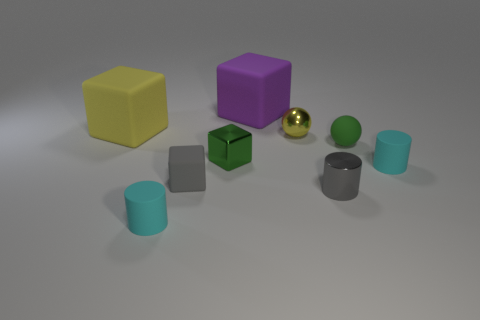What material is the tiny cylinder that is the same color as the tiny matte block?
Provide a short and direct response. Metal. What number of tiny green balls are the same material as the small yellow sphere?
Your answer should be compact. 0. What size is the green object that is the same shape as the yellow shiny thing?
Your answer should be very brief. Small. Does the gray block have the same size as the yellow metallic sphere?
Your answer should be very brief. Yes. There is a matte object that is behind the matte block left of the matte cylinder on the left side of the large purple matte thing; what is its shape?
Give a very brief answer. Cube. What color is the other thing that is the same shape as the yellow shiny thing?
Your answer should be compact. Green. What is the size of the rubber thing that is both behind the green metallic object and to the left of the small gray rubber thing?
Offer a very short reply. Large. There is a cyan rubber thing that is on the right side of the small cyan cylinder on the left side of the purple rubber object; what number of metal spheres are in front of it?
Give a very brief answer. 0. What number of tiny things are either purple objects or red shiny things?
Offer a terse response. 0. Do the tiny cylinder behind the tiny gray cylinder and the tiny gray cylinder have the same material?
Your answer should be very brief. No. 